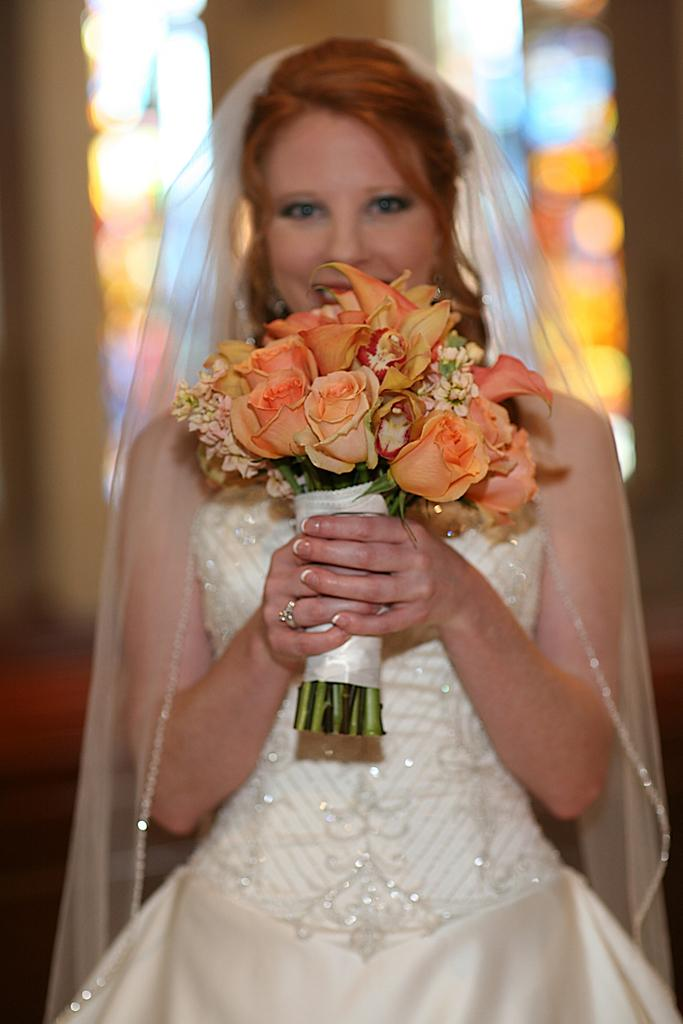Who is the main subject in the image? There is a woman in the image. What is the woman wearing? The woman is wearing a white dress. What is the woman holding in the image? The woman is holding orange flowers. Can you describe the background of the image? The background of the image is blurred. What type of blood is visible on the woman's dress in the image? There is no blood visible on the woman's dress in the image. Can you tell me how many mailboxes are present in the background of the image? There are no mailboxes present in the image; the background is blurred. 